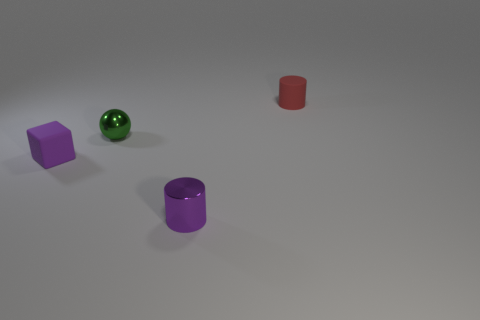Does the object that is behind the tiny green metal ball have the same material as the tiny green thing?
Offer a terse response. No. There is a red object that is the same size as the green ball; what is its material?
Your answer should be very brief. Rubber. What number of other objects are the same material as the tiny block?
Offer a very short reply. 1. Do the red object and the purple object on the right side of the small sphere have the same size?
Ensure brevity in your answer.  Yes. Are there fewer rubber things on the right side of the tiny block than tiny green metallic spheres behind the green shiny ball?
Provide a succinct answer. No. There is a purple thing that is right of the green thing; what is its size?
Keep it short and to the point. Small. Is the size of the shiny cylinder the same as the green shiny sphere?
Offer a very short reply. Yes. What number of small cylinders are both behind the green object and in front of the tiny purple matte object?
Your response must be concise. 0. How many purple things are either tiny balls or tiny cubes?
Give a very brief answer. 1. What number of rubber things are green blocks or tiny spheres?
Your answer should be very brief. 0. 